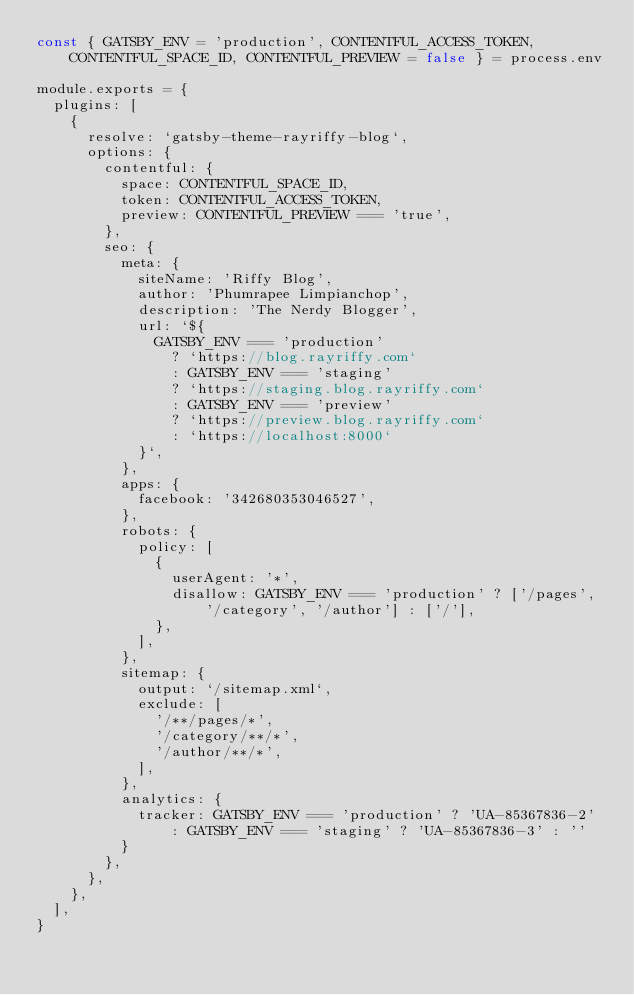Convert code to text. <code><loc_0><loc_0><loc_500><loc_500><_JavaScript_>const { GATSBY_ENV = 'production', CONTENTFUL_ACCESS_TOKEN, CONTENTFUL_SPACE_ID, CONTENTFUL_PREVIEW = false } = process.env

module.exports = {
  plugins: [
    {
      resolve: `gatsby-theme-rayriffy-blog`,
      options: {
        contentful: {
          space: CONTENTFUL_SPACE_ID,
          token: CONTENTFUL_ACCESS_TOKEN,
          preview: CONTENTFUL_PREVIEW === 'true',
        },
        seo: {
          meta: {
            siteName: 'Riffy Blog',
            author: 'Phumrapee Limpianchop',
            description: 'The Nerdy Blogger',
            url: `${
              GATSBY_ENV === 'production'
                ? `https://blog.rayriffy.com`
                : GATSBY_ENV === 'staging'
                ? `https://staging.blog.rayriffy.com`
                : GATSBY_ENV === 'preview'
                ? `https://preview.blog.rayriffy.com`
                : `https://localhost:8000`
            }`,
          },
          apps: {
            facebook: '342680353046527',
          },
          robots: {
            policy: [
              {
                userAgent: '*',
                disallow: GATSBY_ENV === 'production' ? ['/pages', '/category', '/author'] : ['/'],
              },
            ],
          },
          sitemap: {
            output: `/sitemap.xml`,
            exclude: [
              '/**/pages/*',
              '/category/**/*',
              '/author/**/*',
            ],
          },
          analytics: {
            tracker: GATSBY_ENV === 'production' ? 'UA-85367836-2' : GATSBY_ENV === 'staging' ? 'UA-85367836-3' : ''
          }
        },
      },
    },
  ],
}
</code> 